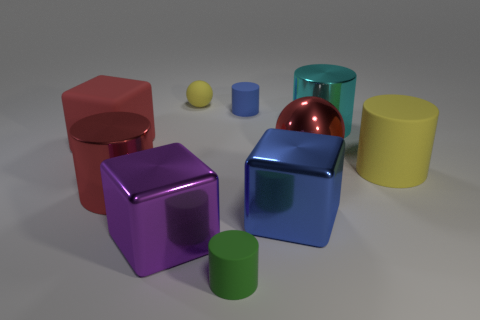Are there any tiny cylinders to the left of the tiny cylinder behind the big matte cylinder?
Give a very brief answer. Yes. There is a rubber cube that is the same size as the blue shiny block; what is its color?
Your answer should be compact. Red. How many objects are small yellow shiny spheres or yellow things?
Offer a terse response. 2. What size is the thing that is to the right of the metallic cylinder behind the big red shiny object that is left of the green cylinder?
Offer a terse response. Large. What number of shiny blocks have the same color as the matte sphere?
Your answer should be compact. 0. How many large red cubes are the same material as the tiny blue cylinder?
Offer a terse response. 1. How many objects are either blue cylinders or big shiny cylinders that are right of the green cylinder?
Your answer should be compact. 2. There is a block that is behind the big shiny cylinder to the left of the big red metallic object to the right of the large purple cube; what is its color?
Provide a succinct answer. Red. What is the size of the matte cylinder to the right of the big blue shiny cube?
Provide a short and direct response. Large. How many large things are either blue objects or blue shiny blocks?
Keep it short and to the point. 1. 